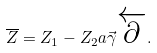<formula> <loc_0><loc_0><loc_500><loc_500>\overline { Z } = Z _ { 1 } - Z _ { 2 } a \vec { \gamma } \overleftarrow { \partial } .</formula> 